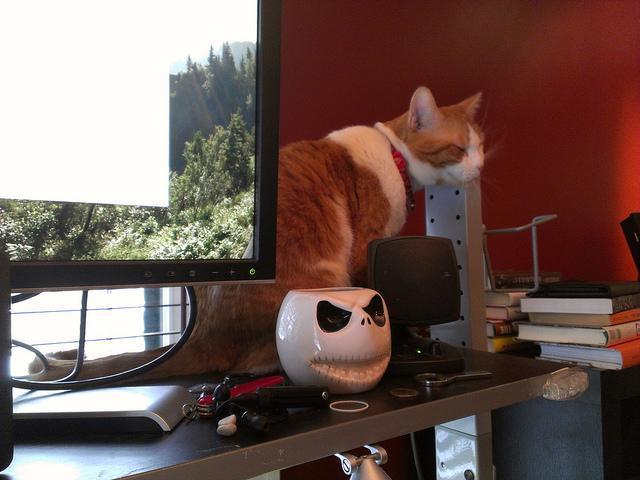How many books can you see?
Give a very brief answer. 2. 